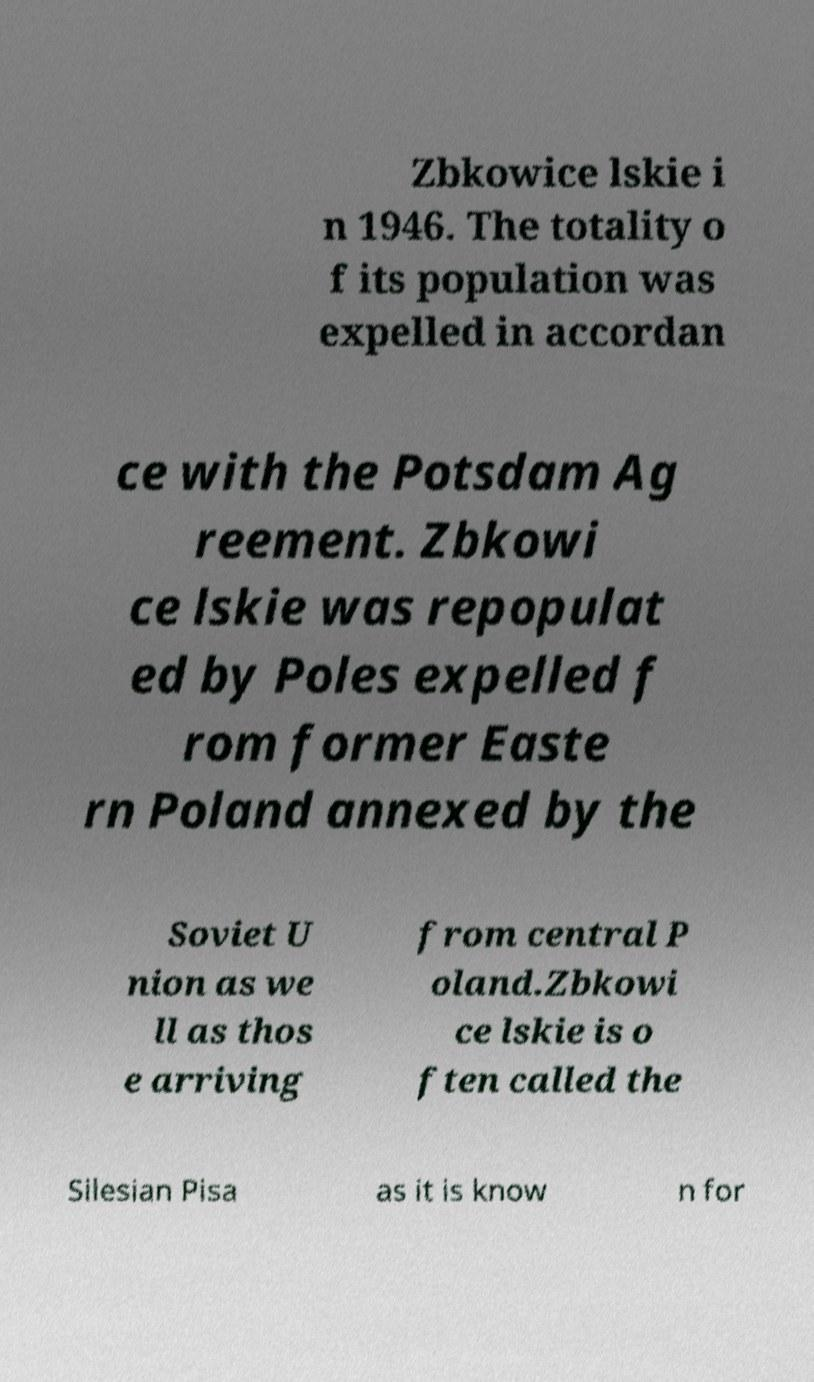What messages or text are displayed in this image? I need them in a readable, typed format. Zbkowice lskie i n 1946. The totality o f its population was expelled in accordan ce with the Potsdam Ag reement. Zbkowi ce lskie was repopulat ed by Poles expelled f rom former Easte rn Poland annexed by the Soviet U nion as we ll as thos e arriving from central P oland.Zbkowi ce lskie is o ften called the Silesian Pisa as it is know n for 